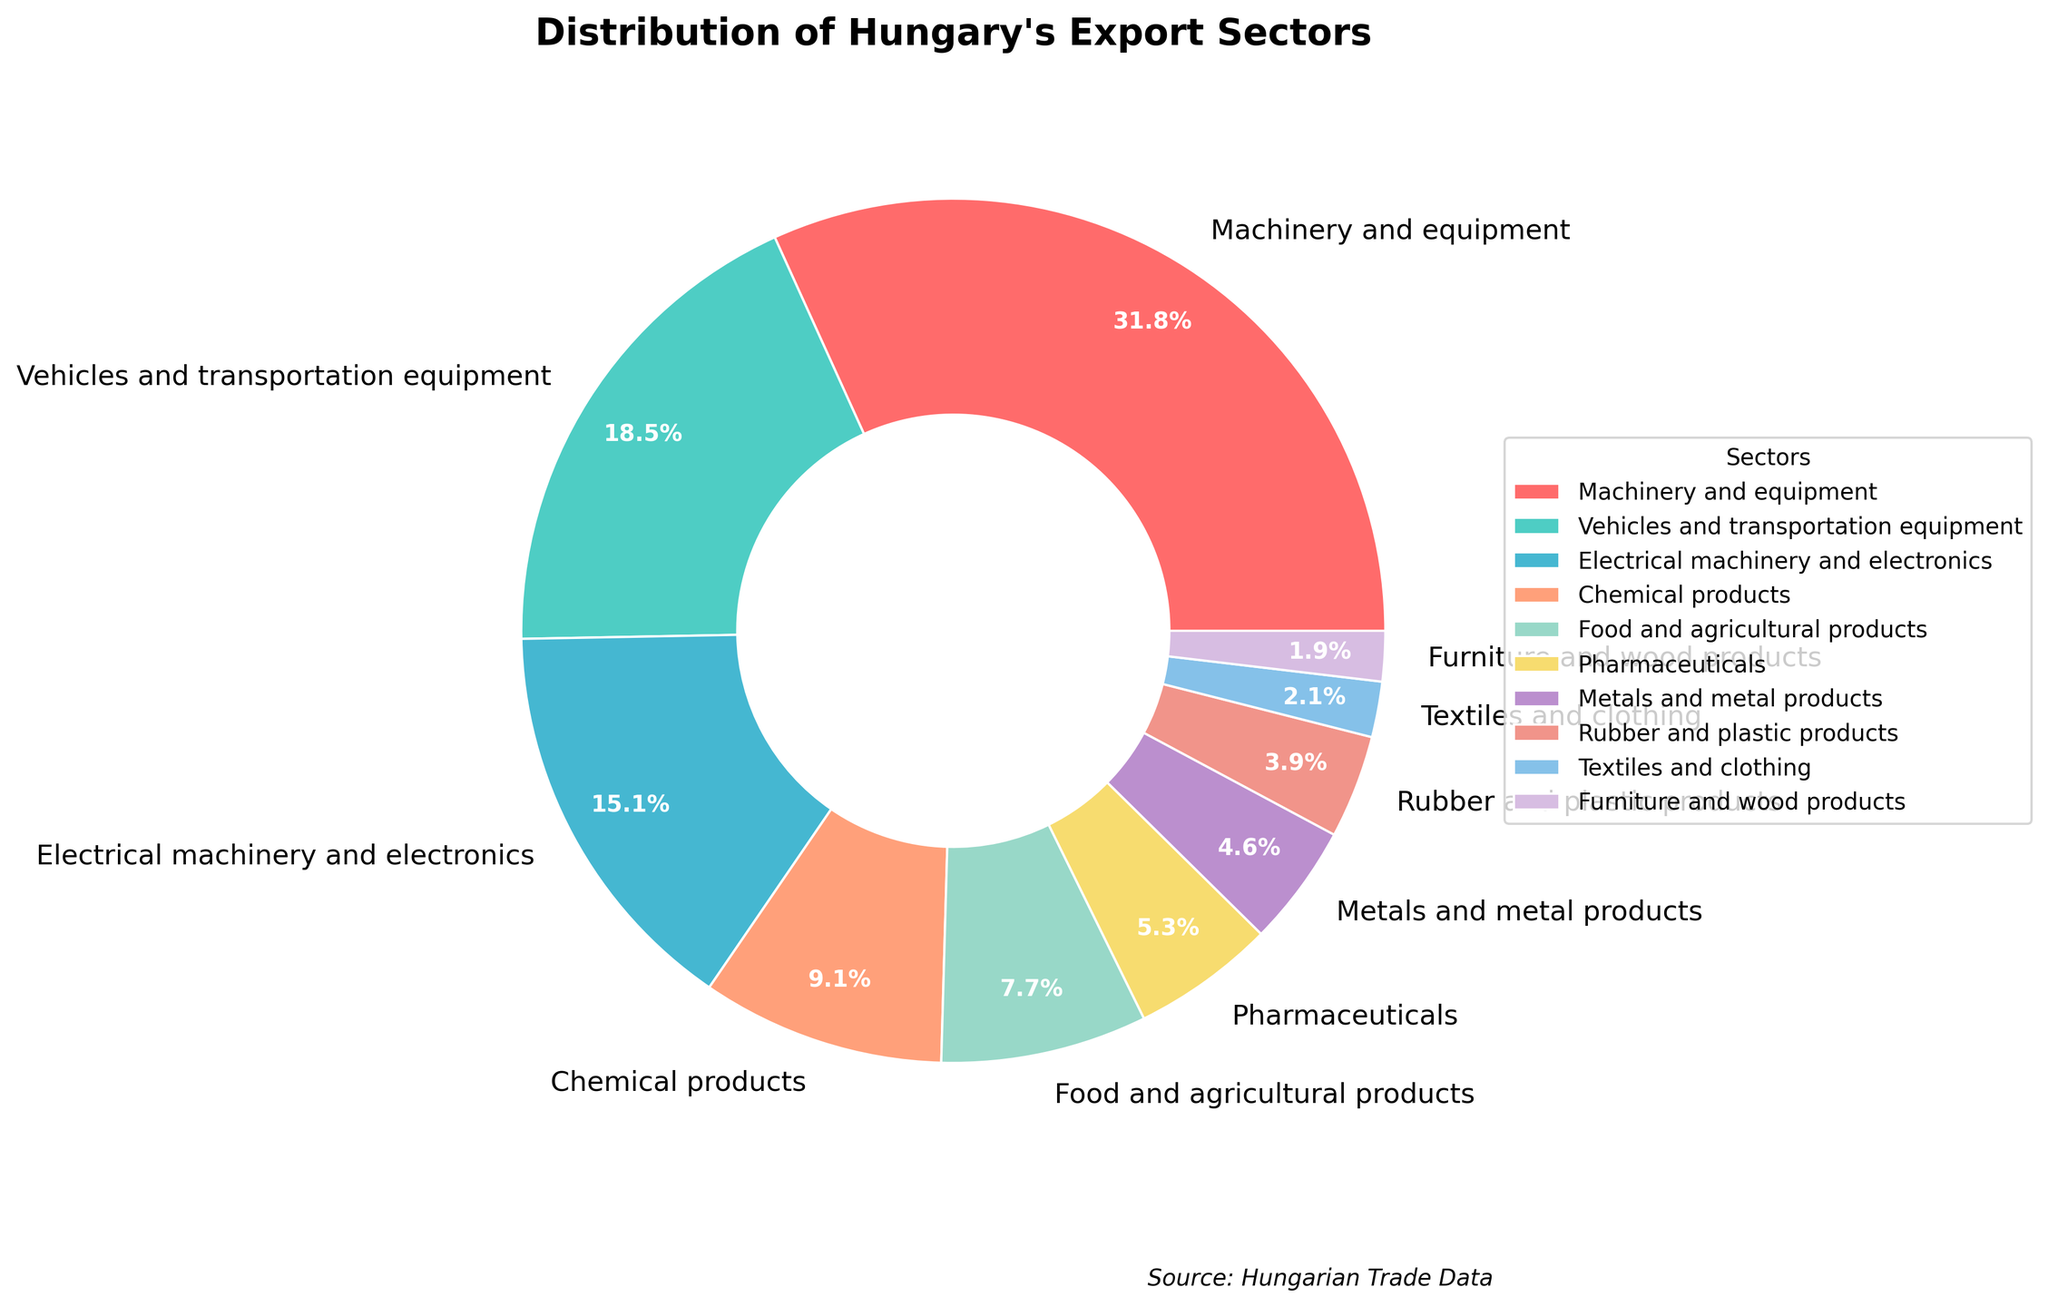Which sector has the highest percentage of Hungary's export? By looking at the figure, it is evident that the sector with the largest wedge and the corresponding percentage in the pie chart is "Machinery and equipment" at 32.1%.
Answer: Machinery and equipment What is the combined percentage of Electrical machinery and electronics and Vehicles and transportation equipment? To find the combined percentage, we need to add the individual percentages of "Electrical machinery and electronics" (15.3%) and "Vehicles and transportation equipment" (18.7%), resulting in a sum of 34%.
Answer: 34% Which sectors have a percentage greater than 10%? By observing the pie chart, we identify the sectors with percentages larger than 10%: "Machinery and equipment" (32.1%), "Vehicles and transportation equipment" (18.7%), and "Electrical machinery and electronics" (15.3%).
Answer: Machinery and equipment, Vehicles and transportation equipment, Electrical machinery and electronics How much more percentage do Machinery and equipment contribute compared to Pharmaceuticals? The percentage for "Machinery and equipment" is 32.1%, and for "Pharmaceuticals", it is 5.4%. The difference is calculated as 32.1% - 5.4% = 26.7%.
Answer: 26.7% Which sector has a slightly larger percentage, Pharmaceuticals or Chemical products? According to the pie chart, "Chemical products" has a percentage of 9.2%, which is larger than "Pharmaceuticals" at 5.4%.
Answer: Chemical products What is the second smallest sector in terms of percentage? The pie chart shows that the smallest sector is "Furniture and wood products" (1.9%), and the second smallest is "Textiles and clothing" (2.1%).
Answer: Textiles and clothing What is the total percentage of sectors that each have a percentage less than 5%? The sectors with percentages less than 5% are: "Pharmaceuticals" (5.4%, not included), "Metals and metal products" (4.6%), "Rubber and plastic products" (3.9%), "Textiles and clothing" (2.1%), and "Furniture and wood products" (1.9%). The sum is 4.6% + 3.9% + 2.1% + 1.9% = 12.5%.
Answer: 12.5% Which sector is represented by the blue wedge in the pie chart? By referring to the color scheme in the figure, the blue wedge corresponds to "Electrical machinery and electronics" with a percentage of 15.3%.
Answer: Electrical machinery and electronics What's the difference between the percentage of Food and agricultural products and Rubber and plastic products? The percentage of "Food and agricultural products" is 7.8%, while "Rubber and plastic products" is 3.9%. The difference is calculated as 7.8% - 3.9% = 3.9%.
Answer: 3.9% 